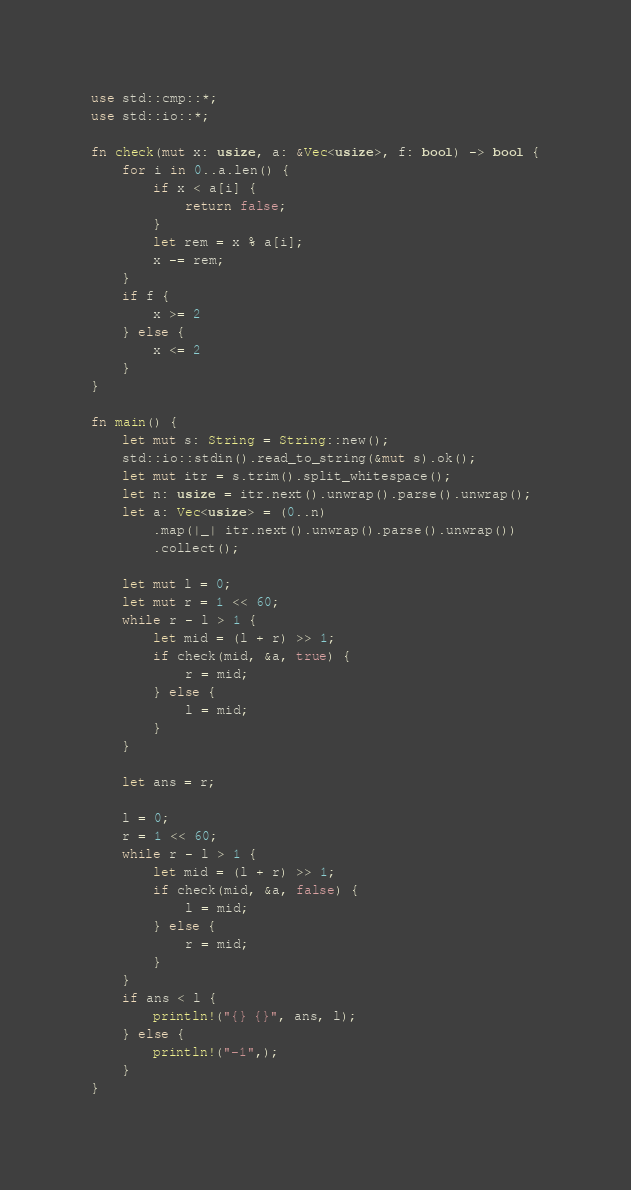<code> <loc_0><loc_0><loc_500><loc_500><_Rust_>use std::cmp::*;
use std::io::*;

fn check(mut x: usize, a: &Vec<usize>, f: bool) -> bool {
    for i in 0..a.len() {
        if x < a[i] {
            return false;
        }
        let rem = x % a[i];
        x -= rem;
    }
    if f {
        x >= 2
    } else {
        x <= 2
    }
}

fn main() {
    let mut s: String = String::new();
    std::io::stdin().read_to_string(&mut s).ok();
    let mut itr = s.trim().split_whitespace();
    let n: usize = itr.next().unwrap().parse().unwrap();
    let a: Vec<usize> = (0..n)
        .map(|_| itr.next().unwrap().parse().unwrap())
        .collect();

    let mut l = 0;
    let mut r = 1 << 60;
    while r - l > 1 {
        let mid = (l + r) >> 1;
        if check(mid, &a, true) {
            r = mid;
        } else {
            l = mid;
        }
    }

    let ans = r;

    l = 0;
    r = 1 << 60;
    while r - l > 1 {
        let mid = (l + r) >> 1;
        if check(mid, &a, false) {
            l = mid;
        } else {
            r = mid;
        }
    }
    if ans < l {
        println!("{} {}", ans, l);
    } else {
        println!("-1",);
    }
}
</code> 